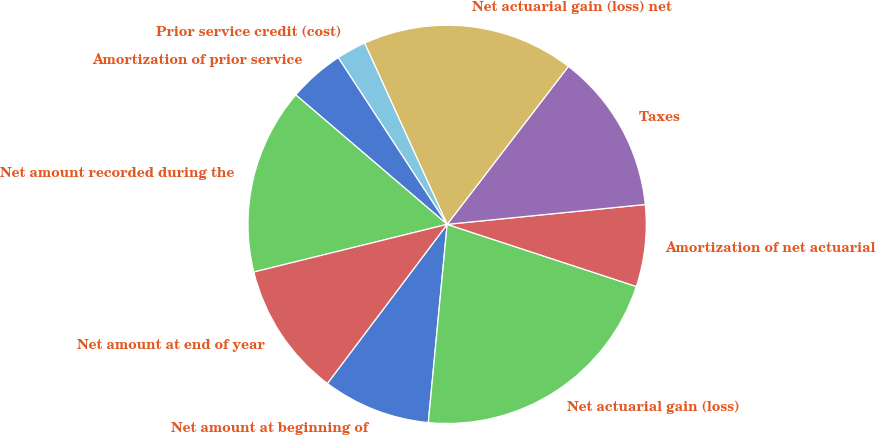<chart> <loc_0><loc_0><loc_500><loc_500><pie_chart><fcel>Net amount at beginning of<fcel>Net actuarial gain (loss)<fcel>Amortization of net actuarial<fcel>Taxes<fcel>Net actuarial gain (loss) net<fcel>Prior service credit (cost)<fcel>Amortization of prior service<fcel>Net amount recorded during the<fcel>Net amount at end of year<nl><fcel>8.76%<fcel>21.46%<fcel>6.64%<fcel>12.99%<fcel>17.22%<fcel>2.41%<fcel>4.53%<fcel>15.11%<fcel>10.88%<nl></chart> 